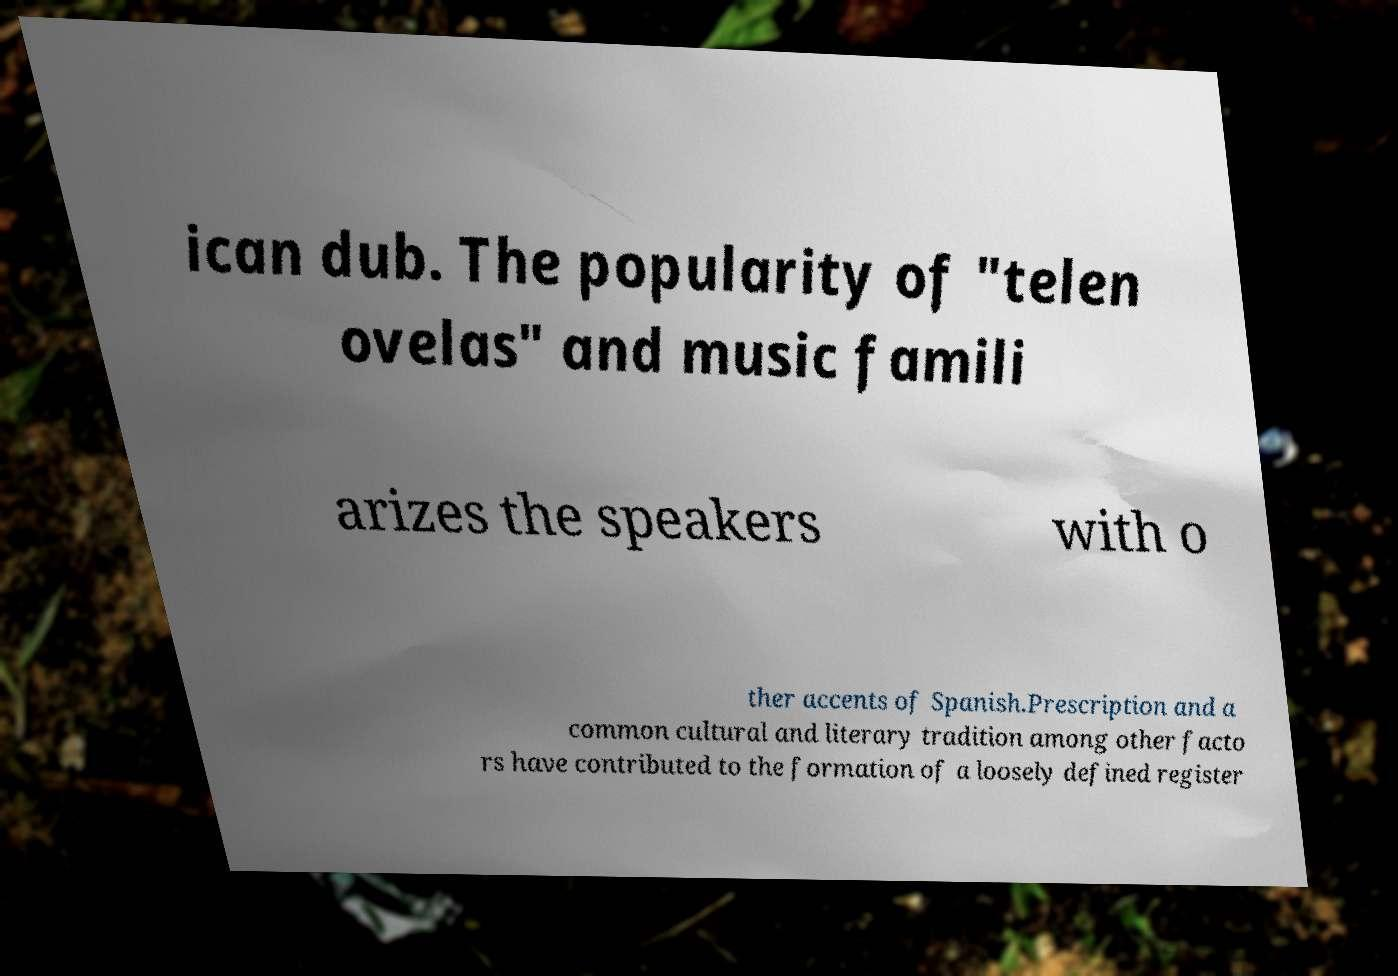There's text embedded in this image that I need extracted. Can you transcribe it verbatim? ican dub. The popularity of "telen ovelas" and music famili arizes the speakers with o ther accents of Spanish.Prescription and a common cultural and literary tradition among other facto rs have contributed to the formation of a loosely defined register 